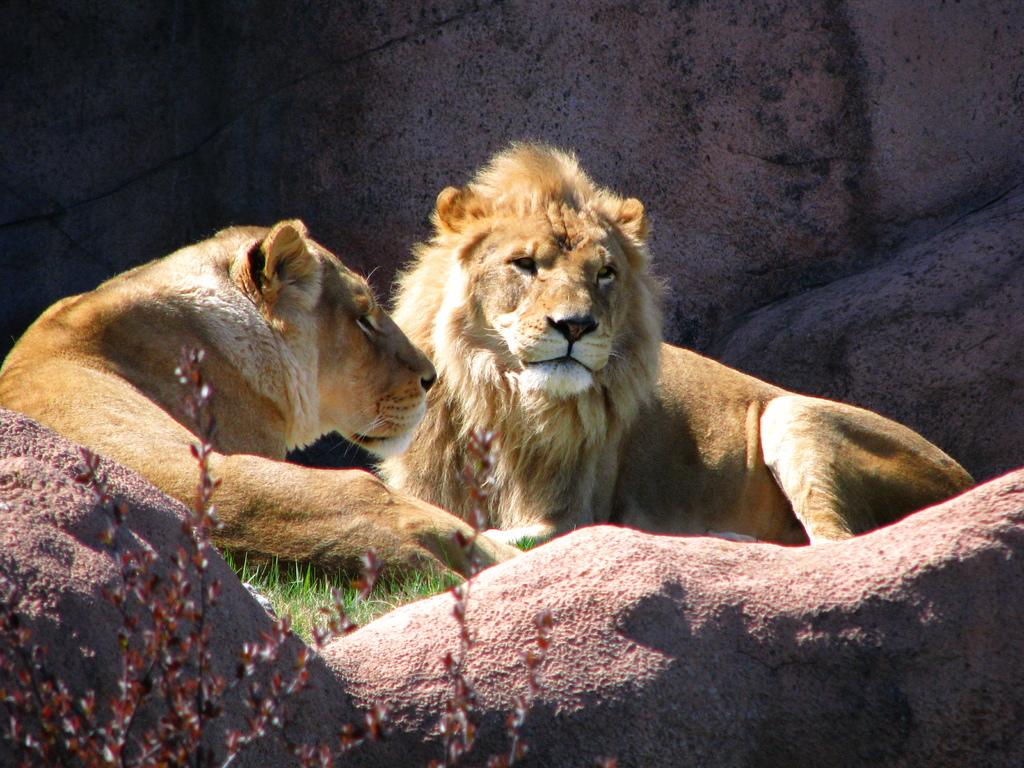What animals can be seen in the picture? There are lions in the picture. Where are the lions located? The lions are sitting on the grass. What other natural elements are present in the image? There are rocks and plants in the image. What type of juice can be seen in the hands of the lions in the image? There is no juice present in the image; the lions are sitting on the grass and there is no mention of any juice in the facts provided. 